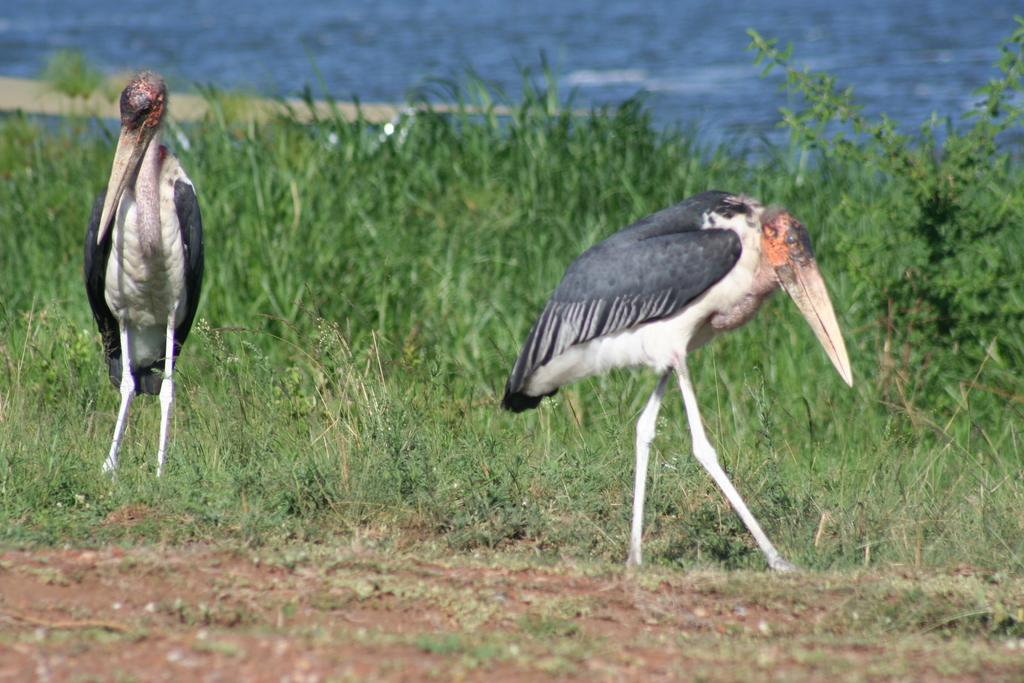What can be seen in the foreground of the image? In the foreground of the image, there is grass, soil, and cranes. What is present in the middle of the image? In the middle of the image, there are plants and more grass. What is located at the top of the image? At the top of the image, there is a water body. How many cherries are hanging from the cranes in the image? There are no cherries present in the image; the cranes are likely construction cranes. What type of error can be seen in the image? There is no error present in the image; it appears to be a clear and accurate representation of the scene. 